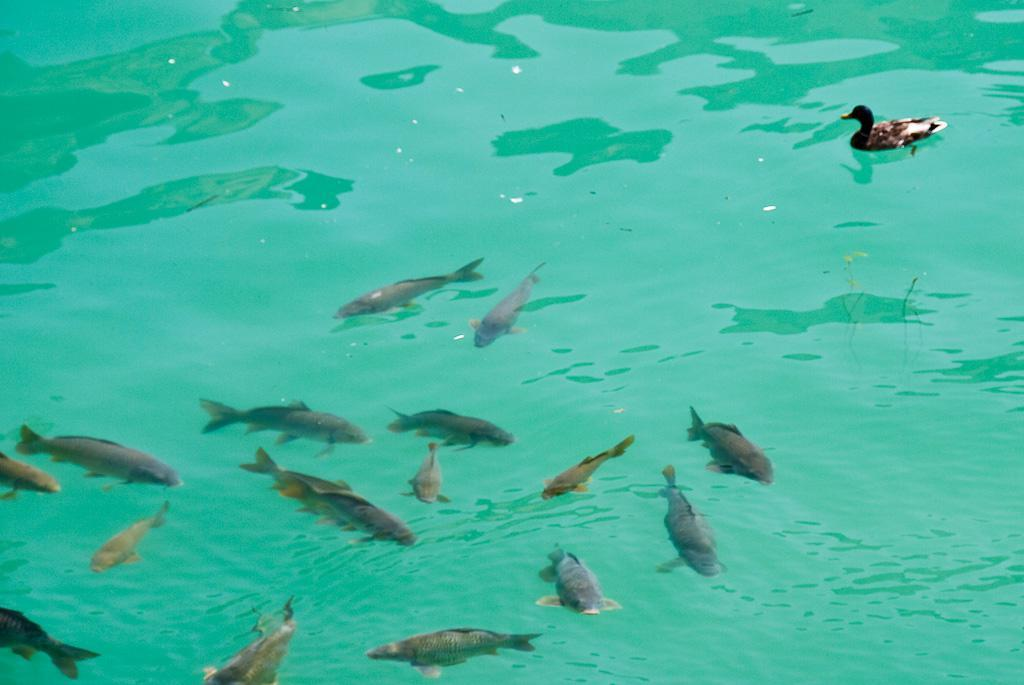What type of animals can be seen in the water in the image? There are fishes in the water in the image. What other animal can be seen in the image? There is a duck on the right side of the image. Where is the pail located in the image? There is no pail present in the image. What type of joke can be seen in the image? There is no joke present in the image; it features fishes in the water and a duck on the right side. 